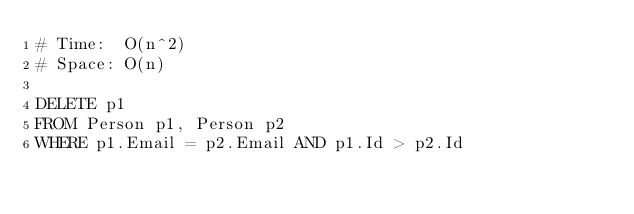<code> <loc_0><loc_0><loc_500><loc_500><_SQL_># Time:  O(n^2)
# Space: O(n)

DELETE p1
FROM Person p1, Person p2
WHERE p1.Email = p2.Email AND p1.Id > p2.Id

</code> 